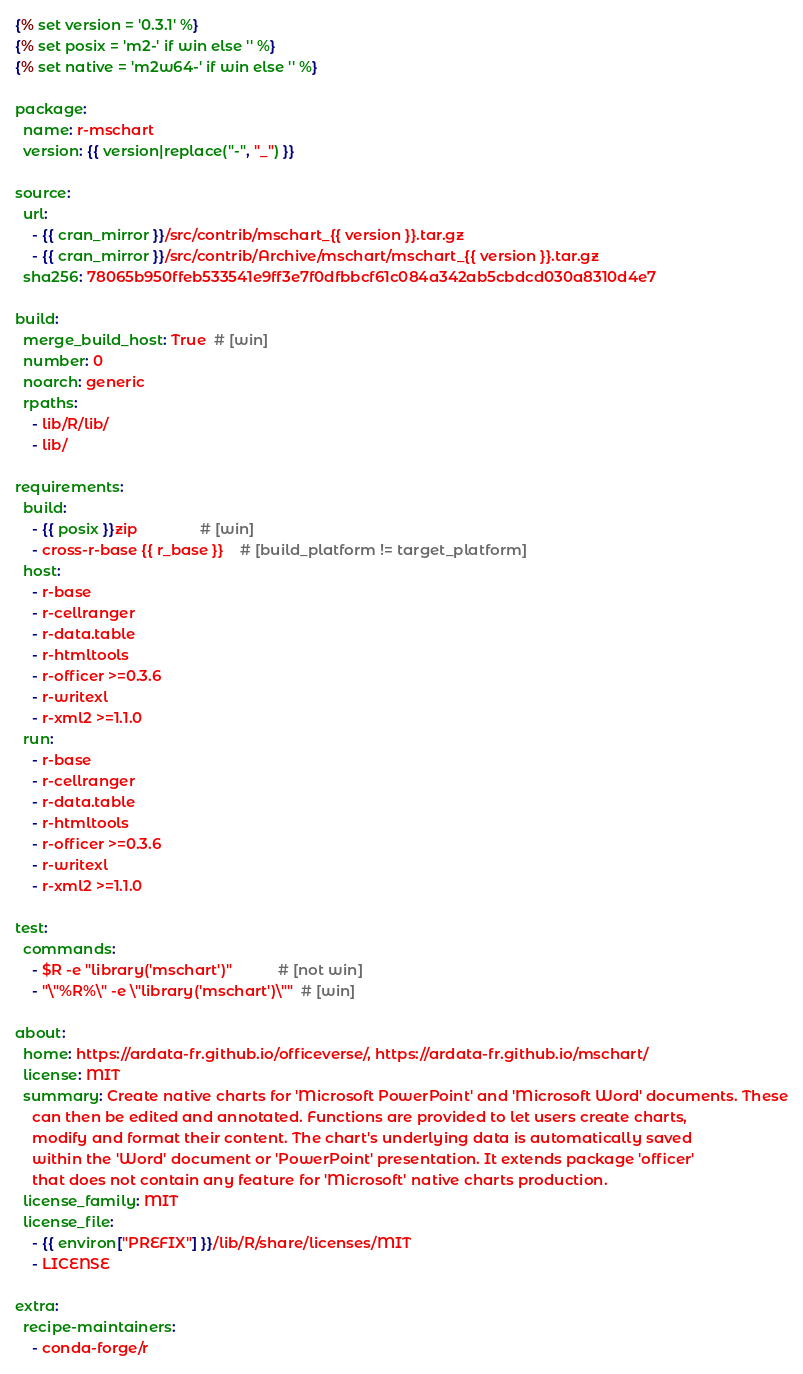<code> <loc_0><loc_0><loc_500><loc_500><_YAML_>{% set version = '0.3.1' %}
{% set posix = 'm2-' if win else '' %}
{% set native = 'm2w64-' if win else '' %}

package:
  name: r-mschart
  version: {{ version|replace("-", "_") }}

source:
  url:
    - {{ cran_mirror }}/src/contrib/mschart_{{ version }}.tar.gz
    - {{ cran_mirror }}/src/contrib/Archive/mschart/mschart_{{ version }}.tar.gz
  sha256: 78065b950ffeb533541e9ff3e7f0dfbbcf61c084a342ab5cbdcd030a8310d4e7

build:
  merge_build_host: True  # [win]
  number: 0
  noarch: generic
  rpaths:
    - lib/R/lib/
    - lib/

requirements:
  build:
    - {{ posix }}zip               # [win]
    - cross-r-base {{ r_base }}    # [build_platform != target_platform]
  host:
    - r-base
    - r-cellranger
    - r-data.table
    - r-htmltools
    - r-officer >=0.3.6
    - r-writexl
    - r-xml2 >=1.1.0
  run:
    - r-base
    - r-cellranger
    - r-data.table
    - r-htmltools
    - r-officer >=0.3.6
    - r-writexl
    - r-xml2 >=1.1.0

test:
  commands:
    - $R -e "library('mschart')"           # [not win]
    - "\"%R%\" -e \"library('mschart')\""  # [win]

about:
  home: https://ardata-fr.github.io/officeverse/, https://ardata-fr.github.io/mschart/
  license: MIT
  summary: Create native charts for 'Microsoft PowerPoint' and 'Microsoft Word' documents. These
    can then be edited and annotated. Functions are provided to let users create charts,
    modify and format their content. The chart's underlying data is automatically saved
    within the 'Word' document or 'PowerPoint' presentation. It extends package 'officer'
    that does not contain any feature for 'Microsoft' native charts production.
  license_family: MIT
  license_file:
    - {{ environ["PREFIX"] }}/lib/R/share/licenses/MIT
    - LICENSE

extra:
  recipe-maintainers:
    - conda-forge/r
</code> 